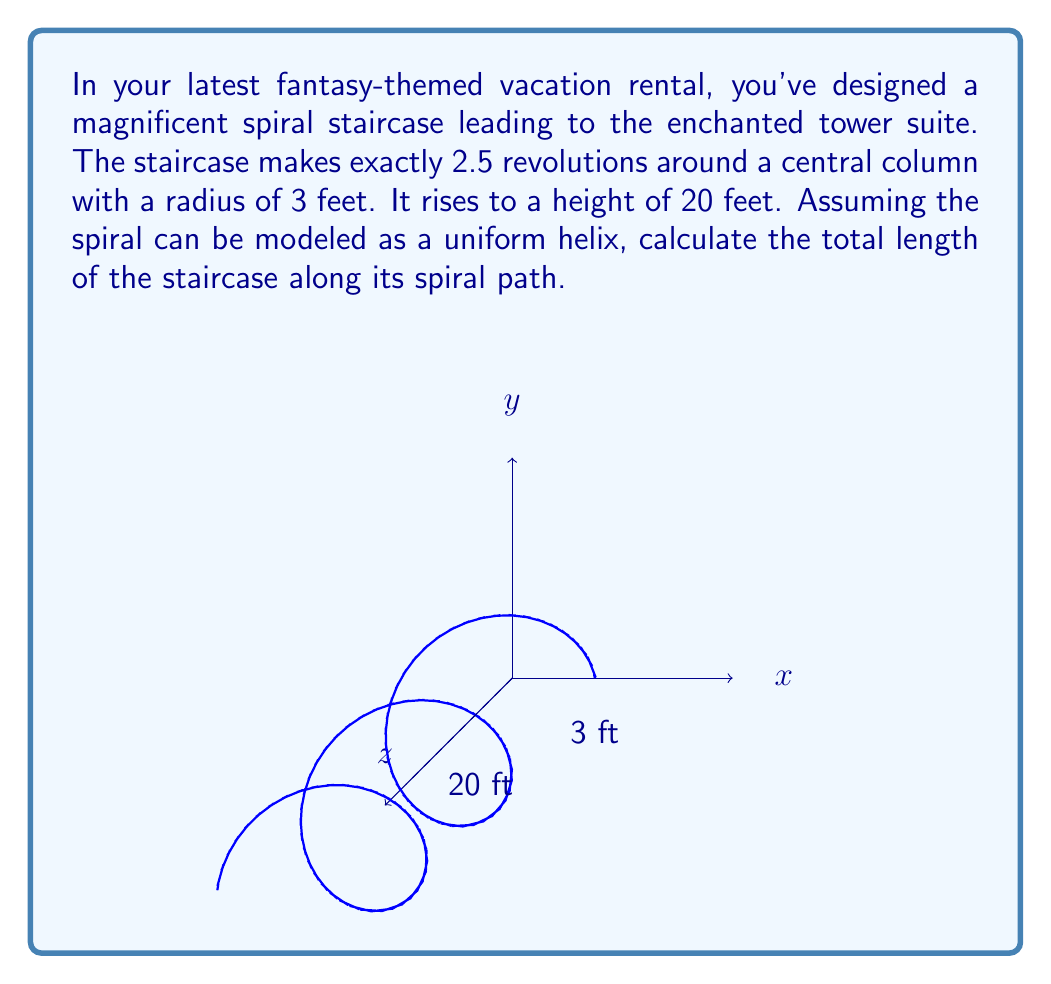Solve this math problem. To find the length of the spiral staircase, we need to use the formula for the arc length of a helix in polar coordinates. Let's approach this step-by-step:

1) The parametric equations for a helix are:
   $x = R \cos(t)$
   $y = R \sin(t)$
   $z = ct$
   where $R$ is the radius, $t$ is the parameter, and $c$ is a constant.

2) In our case, $R = 3$ feet, and we need to find $c$. We know that when the helix completes 2.5 revolutions, $z = 20$ feet. So:
   $20 = c(2.5 \cdot 2\pi)$
   $c = \frac{20}{5\pi} = \frac{4}{\pi}$

3) The formula for the arc length of a helix is:
   $L = \sqrt{R^2 + c^2} \cdot t$
   where $t$ is the total angle swept in radians.

4) We know $t = 2.5 \cdot 2\pi = 5\pi$ radians.

5) Substituting our values:
   $L = \sqrt{3^2 + (\frac{4}{\pi})^2} \cdot 5\pi$

6) Simplifying:
   $L = \sqrt{9 + \frac{16}{\pi^2}} \cdot 5\pi$
   $L = 5\pi\sqrt{9 + \frac{16}{\pi^2}}$
   $L = 5\pi\sqrt{\frac{9\pi^2 + 16}{\pi^2}}$

7) Calculating the value (rounded to two decimal places):
   $L \approx 47.12$ feet
Answer: $47.12$ feet 